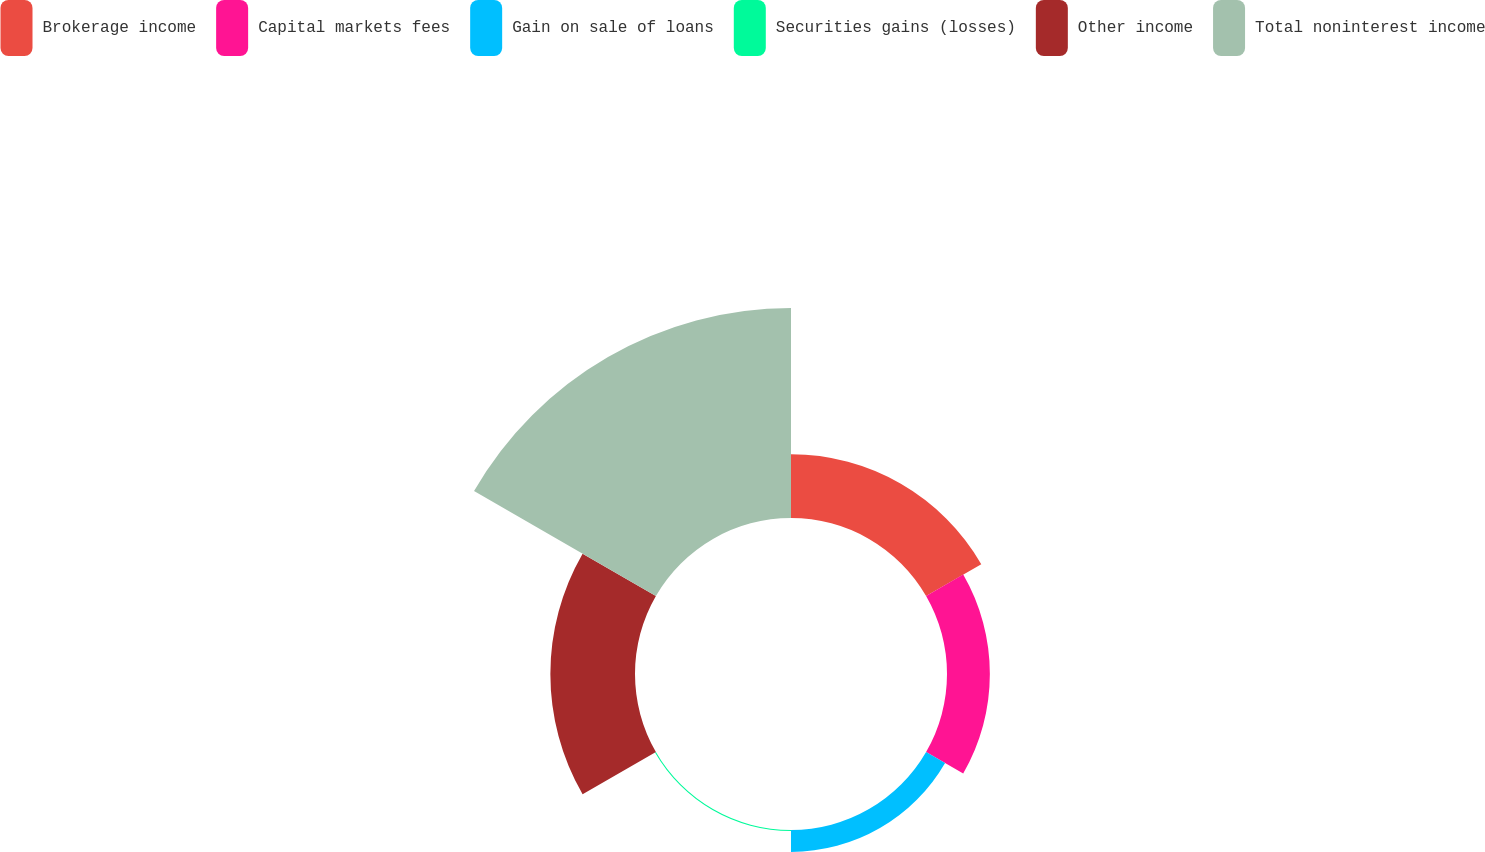<chart> <loc_0><loc_0><loc_500><loc_500><pie_chart><fcel>Brokerage income<fcel>Capital markets fees<fcel>Gain on sale of loans<fcel>Securities gains (losses)<fcel>Other income<fcel>Total noninterest income<nl><fcel>15.02%<fcel>10.1%<fcel>5.17%<fcel>0.25%<fcel>19.95%<fcel>49.5%<nl></chart> 